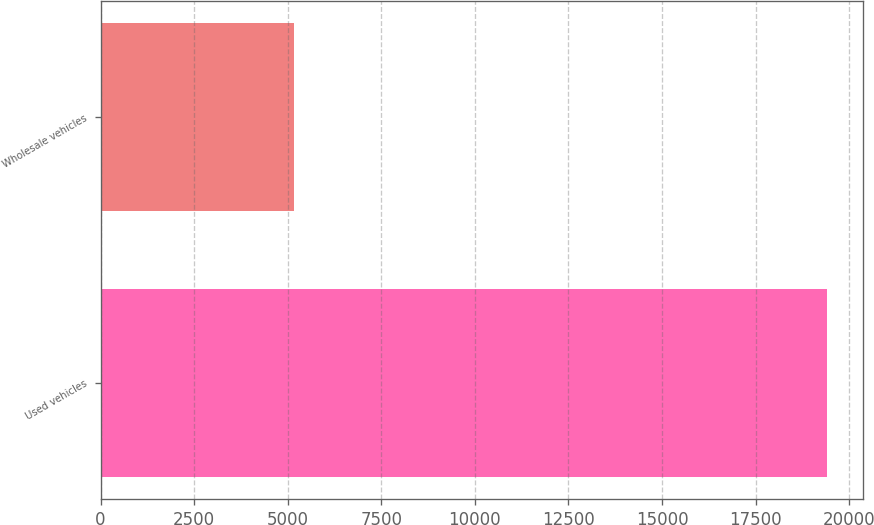Convert chart to OTSL. <chart><loc_0><loc_0><loc_500><loc_500><bar_chart><fcel>Used vehicles<fcel>Wholesale vehicles<nl><fcel>19408<fcel>5160<nl></chart> 